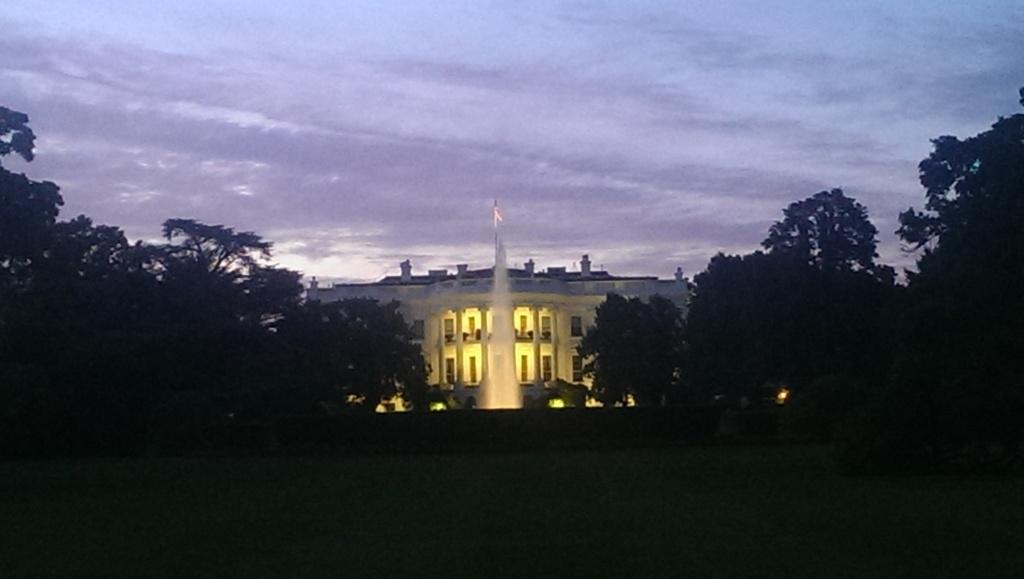Describe this image in one or two sentences. In the image there is a fountain and behind the fountain there is a building, there are a lot of trees around the fountain. 